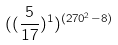<formula> <loc_0><loc_0><loc_500><loc_500>( ( \frac { 5 } { 1 7 } ) ^ { 1 } ) ^ { ( 2 7 0 ^ { 2 } - 8 ) }</formula> 